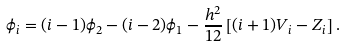<formula> <loc_0><loc_0><loc_500><loc_500>\phi _ { i } = ( i - 1 ) \phi _ { 2 } - ( i - 2 ) \phi _ { 1 } - \frac { h ^ { 2 } } { 1 2 } \left [ ( i + 1 ) V _ { i } - Z _ { i } \right ] .</formula> 